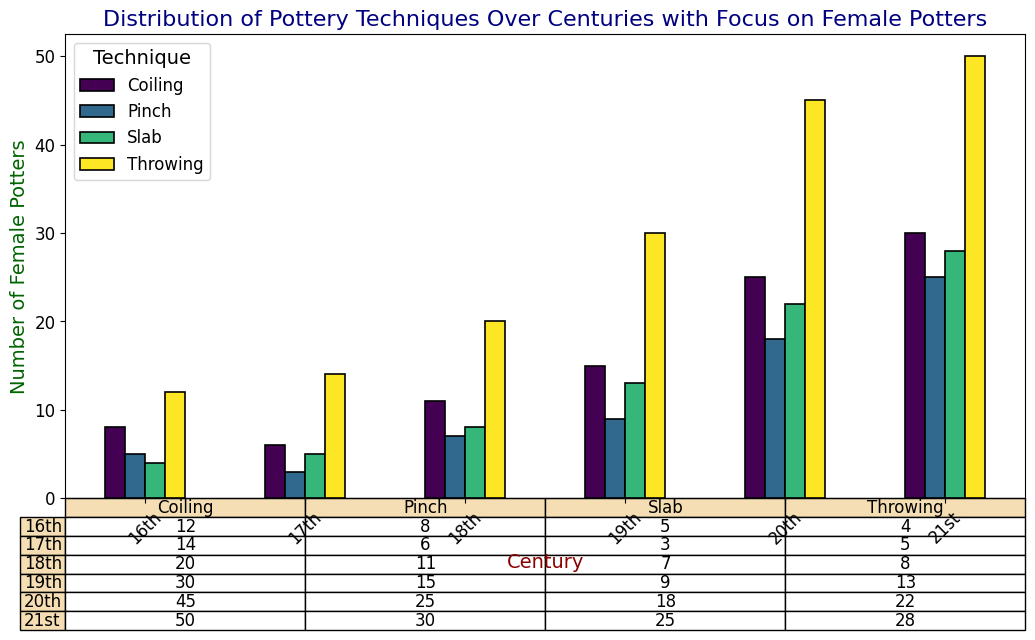Which century had the highest number of female potters using the Throwing technique? Observe the bar heights labeled for the Throwing technique across all centuries. The 21st century bar is the highest indicating 50 female potters.
Answer: 21st Which technique was used the least by female potters in the 16th century? Look at the table under the 16th century row. The Slab technique has the lowest number at 4.
Answer: Slab How many more female potters used the Coiling technique in the 20th century compared to the 17th century? Find the Coiling numbers for both centuries in the table. For the 20th century, it is 25, and for the 17th century, it is 6. Calculate the difference: 25 - 6 = 19.
Answer: 19 What is the overall trend in the number of female potters using the Pinch technique from the 16th to the 21st century? Track the bar heights for the Pinch technique across the centuries. They increase consistently from 5 in the 16th century to 25 in the 21st century.
Answer: Increasing In which centuries did over 20 female potters use the Throwing technique? Check the table and bars for the Throwing values: 18th century (20), 19th century (30), 20th century (45), 21st century (50).
Answer: 18th, 19th, 20th, 21st How does the number of female potters using the Slab technique in the 18th century compare to the 21st century? Compare the Slab values in the table: 8 female potters in the 18th century and 28 in the 21st century.
Answer: More in the 21st century What is the sum of female potters using the Coiling technique in the 18th and 19th centuries? Add the Coiling values from the 18th (11) and 19th (15) centuries: 11 + 15 = 26.
Answer: 26 Which technique showed the most significant increase in the number of female potters from the 19th to the 20th century? Compare the differences for each technique: Throwing 15 (30 to 45), Coiling 10 (15 to 25), Pinch 9 (9 to 18), Slab 9 (13 to 22). The Throwing technique had the largest difference.
Answer: Throwing 